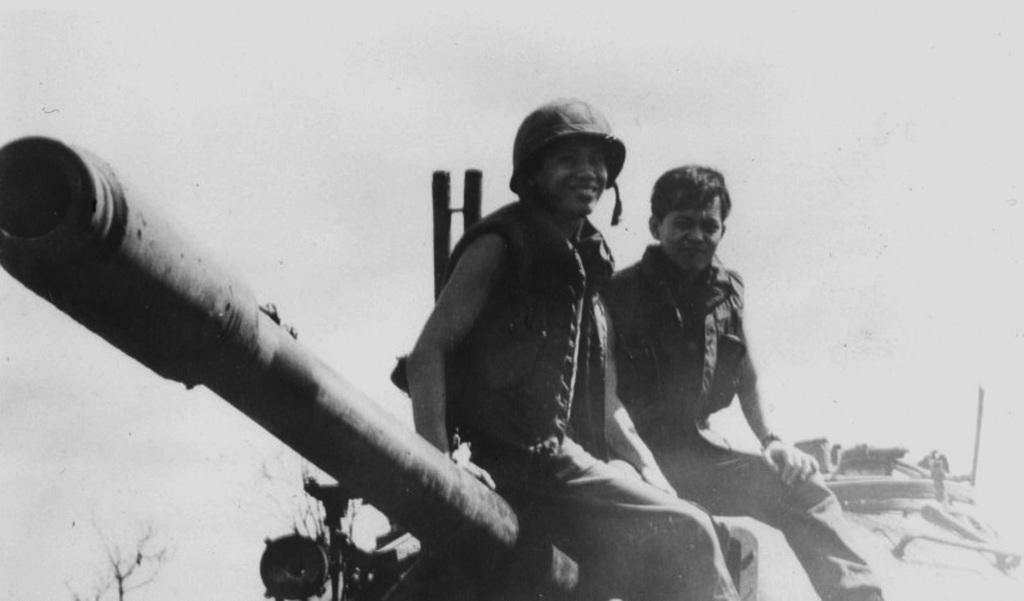What is the color scheme of the image? The image is black and white. What are the two persons doing in the image? They are sitting on a battle tank. What type of vegetation can be seen in the image? There are trees visible in the image. What is visible in the background of the image? The sky is visible in the background of the image. What type of produce is being harvested by the bee in the image? There is no bee or produce present in the image. What is the tax rate for the battle tank in the image? There is no information about tax rates in the image, as it features two persons sitting on a battle tank. 